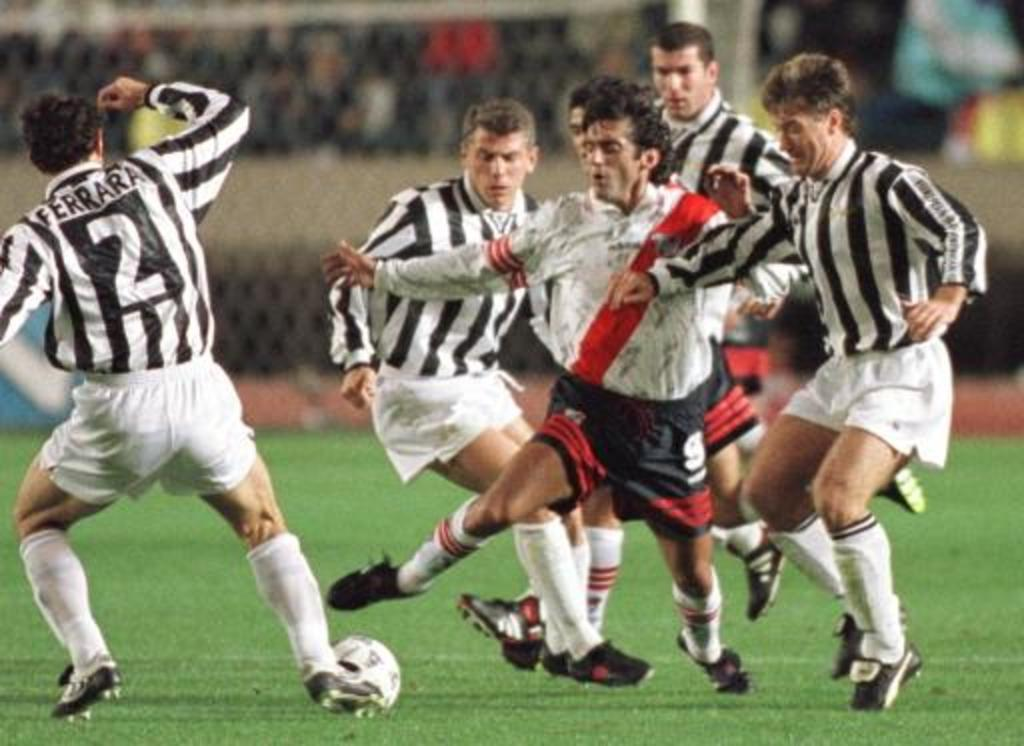<image>
Share a concise interpretation of the image provided. Ferarra among other players try to get possession of the soccer ball. 